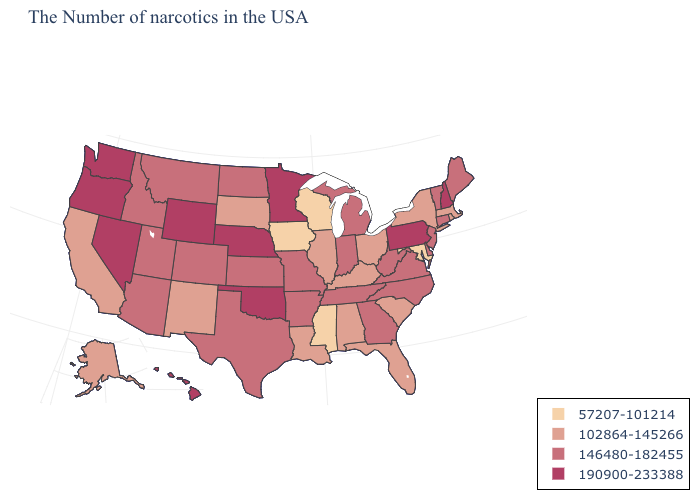Which states have the lowest value in the USA?
Concise answer only. Maryland, Wisconsin, Mississippi, Iowa. Which states have the lowest value in the USA?
Concise answer only. Maryland, Wisconsin, Mississippi, Iowa. Name the states that have a value in the range 102864-145266?
Give a very brief answer. Massachusetts, Rhode Island, New York, South Carolina, Ohio, Florida, Kentucky, Alabama, Illinois, Louisiana, South Dakota, New Mexico, California, Alaska. Name the states that have a value in the range 146480-182455?
Write a very short answer. Maine, Vermont, Connecticut, New Jersey, Delaware, Virginia, North Carolina, West Virginia, Georgia, Michigan, Indiana, Tennessee, Missouri, Arkansas, Kansas, Texas, North Dakota, Colorado, Utah, Montana, Arizona, Idaho. Does Massachusetts have the lowest value in the USA?
Answer briefly. No. What is the lowest value in the USA?
Quick response, please. 57207-101214. Among the states that border South Dakota , which have the lowest value?
Give a very brief answer. Iowa. Does the first symbol in the legend represent the smallest category?
Answer briefly. Yes. Among the states that border New Jersey , which have the lowest value?
Concise answer only. New York. Which states have the lowest value in the USA?
Quick response, please. Maryland, Wisconsin, Mississippi, Iowa. Name the states that have a value in the range 146480-182455?
Give a very brief answer. Maine, Vermont, Connecticut, New Jersey, Delaware, Virginia, North Carolina, West Virginia, Georgia, Michigan, Indiana, Tennessee, Missouri, Arkansas, Kansas, Texas, North Dakota, Colorado, Utah, Montana, Arizona, Idaho. What is the value of Massachusetts?
Write a very short answer. 102864-145266. What is the value of South Carolina?
Write a very short answer. 102864-145266. Does Minnesota have the highest value in the USA?
Answer briefly. Yes. 